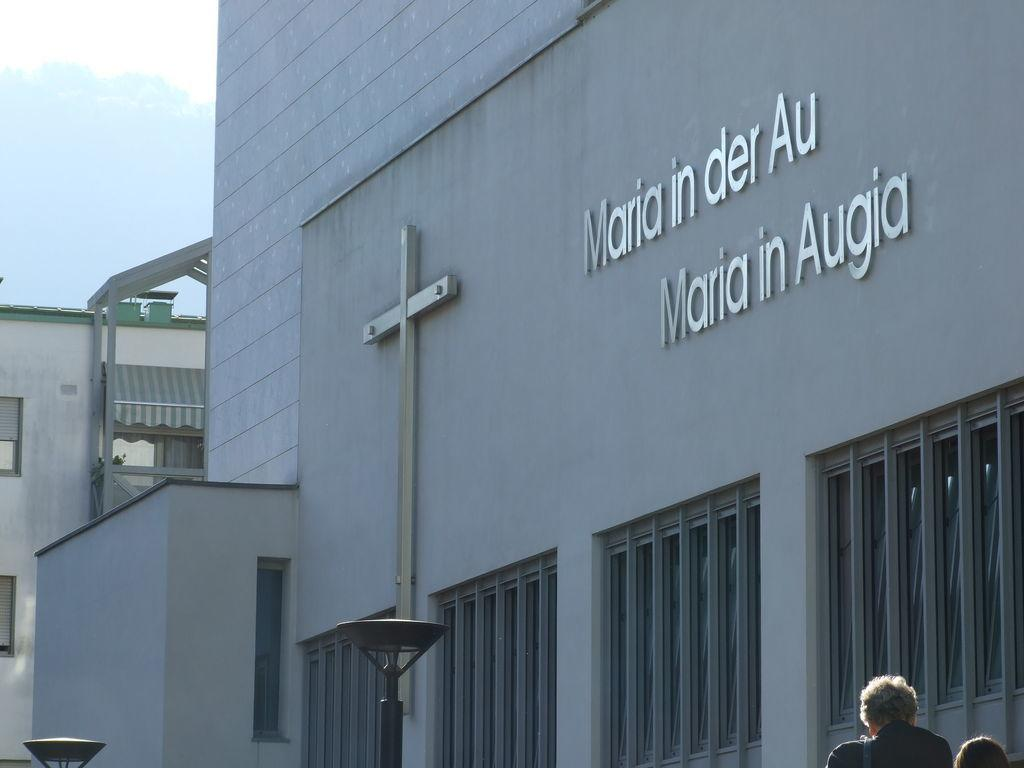What type of structure is present in the image? There is a building in the image. What can be seen on the building? The building has text on it. What are the light sources in the image? There are light poles in the image. Who or what is present in the image besides the building? There are people in the image. What architectural features can be seen on the building? There are windows on the building. What type of amusement can be seen in the image? There is no amusement present in the image; it features a building with text, light poles, and people. Can you describe the wheel-like object in the image? There is no wheel-like object present in the image. 